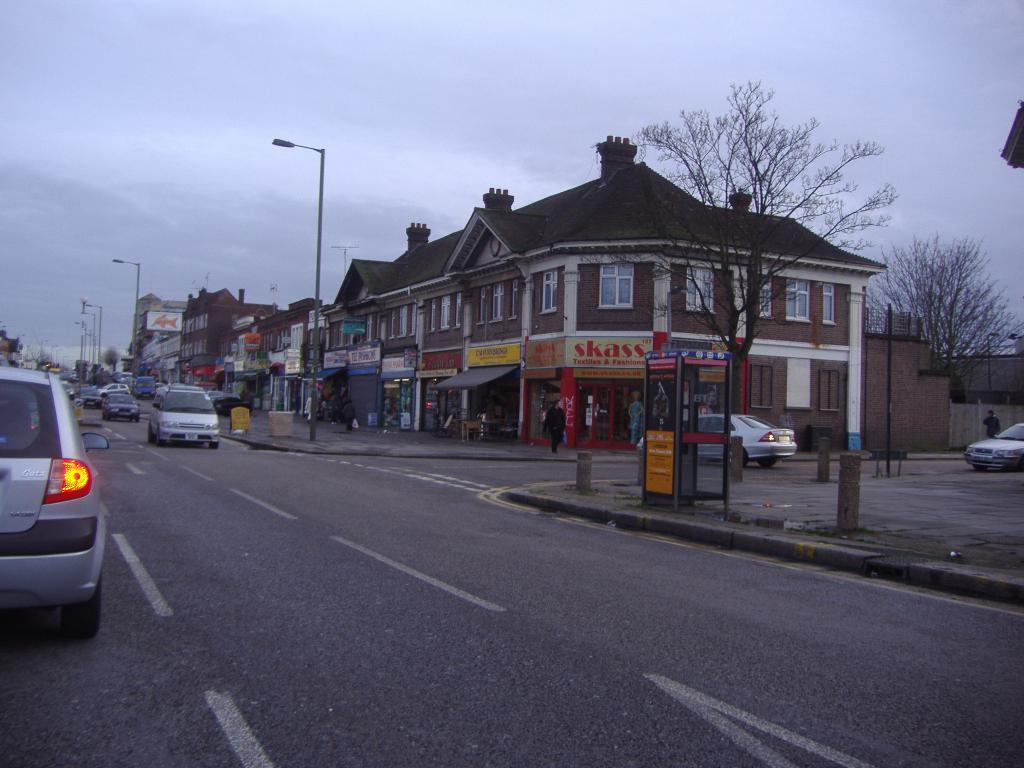Describe this image in one or two sentences. In this image on the right side there are some buildings, trees, poles and shutter, tent and glass doors and some other objects. And on the left side there are some vehicles on the road, and at the top there is sky. 